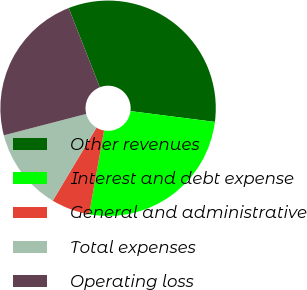<chart> <loc_0><loc_0><loc_500><loc_500><pie_chart><fcel>Other revenues<fcel>Interest and debt expense<fcel>General and administrative<fcel>Total expenses<fcel>Operating loss<nl><fcel>32.98%<fcel>25.8%<fcel>5.77%<fcel>12.37%<fcel>23.08%<nl></chart> 